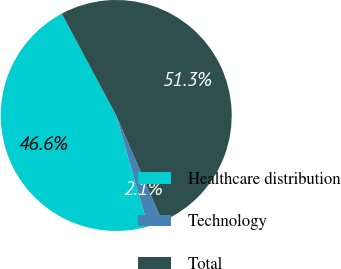<chart> <loc_0><loc_0><loc_500><loc_500><pie_chart><fcel>Healthcare distribution<fcel>Technology<fcel>Total<nl><fcel>46.62%<fcel>2.09%<fcel>51.29%<nl></chart> 